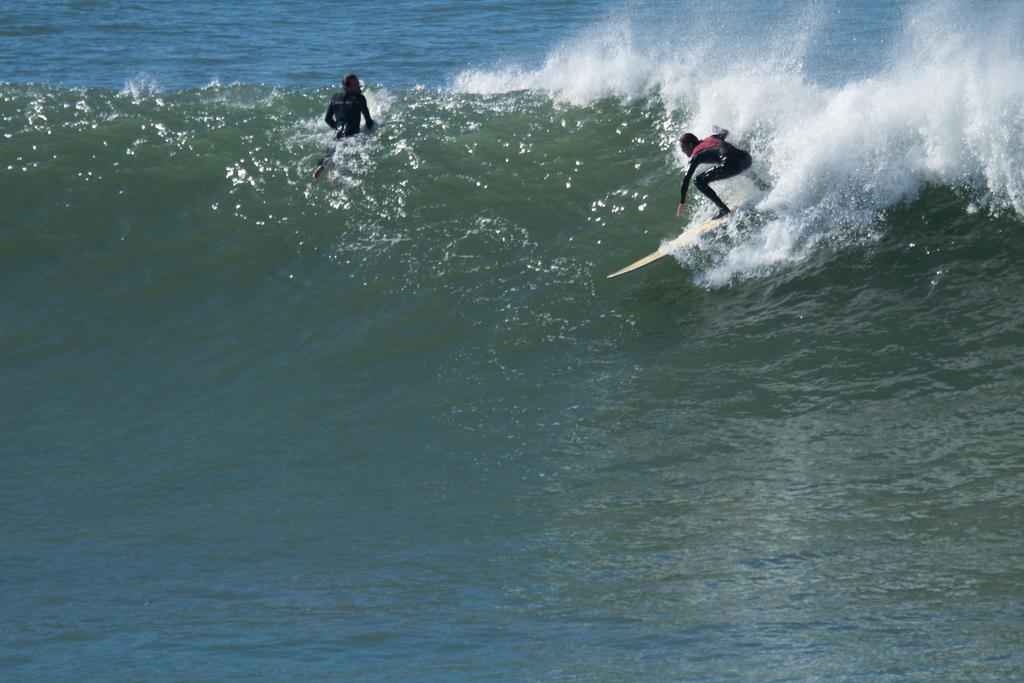How many people are in the image? There are two persons in the image. What are the persons doing in the image? The persons are surfing on boards. Where is the activity taking place? The activity is taking place on water. Can you describe the type of water in the image? The water appears to be an ocean. What type of star can be seen playing a musical instrument in the image? There is no star or musical instrument present in the image; it features two persons surfing on boards in an ocean. 